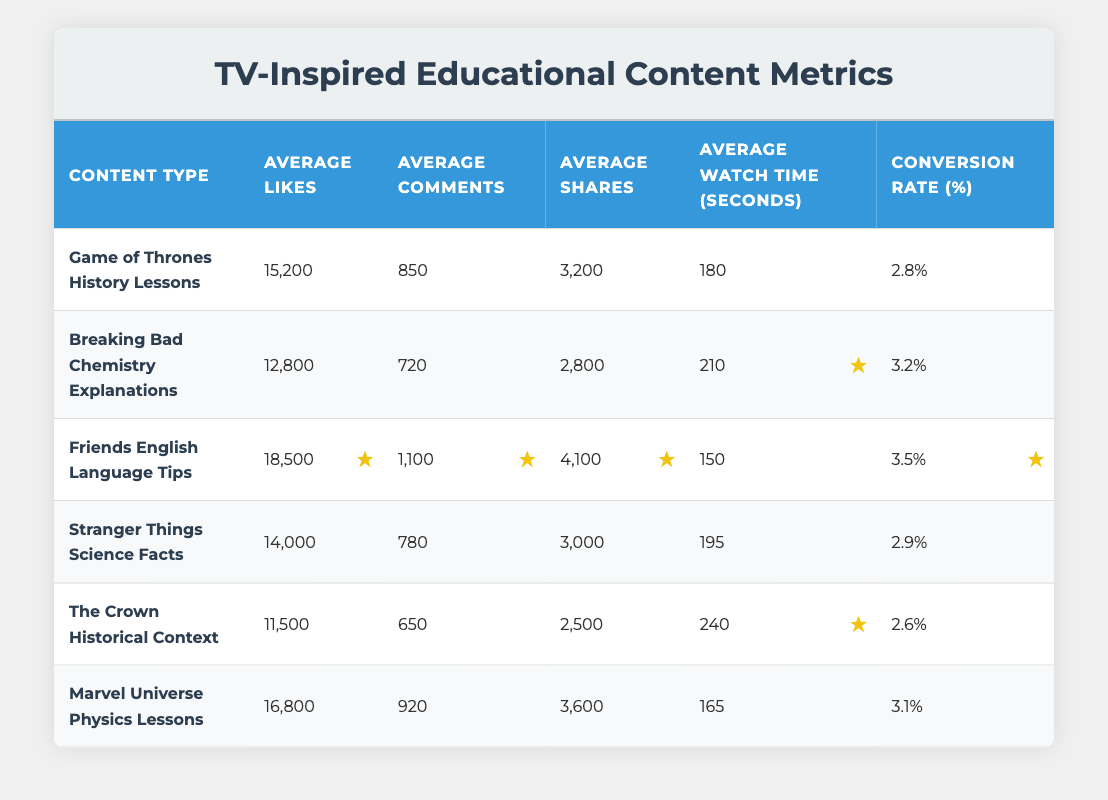What is the average number of likes for "Friends English Language Tips"? The table shows that "Friends English Language Tips" has 18,500 average likes listed in the corresponding row.
Answer: 18,500 Which content type has the highest average watch time? By reviewing the "Average Watch Time (seconds)" column, I see that "The Crown Historical Context" has the highest watch time with 240 seconds.
Answer: The Crown Historical Context Is the average conversion rate for "Breaking Bad Chemistry Explanations" above 3%? The table displays a conversion rate of 3.2% for "Breaking Bad Chemistry Explanations," which is indeed above 3%.
Answer: Yes How many more shares does "Friends English Language Tips" have compared to "The Crown Historical Context"? From the table, "Friends English Language Tips" has 4,100 shares, while "The Crown Historical Context" has 2,500 shares. To find the difference: 4,100 - 2,500 = 1,600.
Answer: 1,600 Which content type has the lowest average likes, and what is that number? Scanning the "Average Likes" column, I find that "The Crown Historical Context" has the lowest with 11,500 likes.
Answer: The Crown Historical Context, 11,500 What is the combined average number of comments for "Stranger Things Science Facts" and "Game of Thrones History Lessons"? The average comments for "Stranger Things Science Facts" is 780, and for "Game of Thrones History Lessons," it is 850. Combining these gives: 780 + 850 = 1,630.
Answer: 1,630 Does "Marvel Universe Physics Lessons" have a higher average engagement (likes, comments, shares combined) than "Game of Thrones History Lessons"? For "Marvel Universe Physics Lessons," the sum is 16,800 (likes) + 920 (comments) + 3,600 (shares) = 21,320. For "Game of Thrones History Lessons," the sum is 15,200 (likes) + 850 (comments) + 3,200 (shares) = 19,250. Since 21,320 is greater than 19,250, the answer is yes.
Answer: Yes What is the average conversion rate among all listed content types? The conversion rates are: 2.8, 3.2, 3.5, 2.9, 2.6, and 3.1. Adding these rates gives 17.1. To find the average: 17.1 / 6 = 2.85.
Answer: 2.85 How does the average watch time compare between "Friends English Language Tips" and "Marvel Universe Physics Lessons"? "Friends English Language Tips" has an average watch time of 150 seconds, while "Marvel Universe Physics Lessons" has 165 seconds. Comparing these, 165 seconds is greater than 150 seconds, indicating that "Marvel Universe Physics Lessons" has a longer average watch time.
Answer: Marvel Universe Physics Lessons has a longer average watch time 